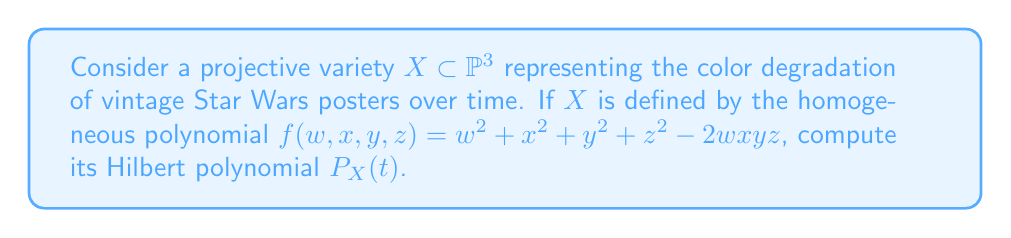Could you help me with this problem? To compute the Hilbert polynomial for this projective variety, we'll follow these steps:

1) First, we need to determine the degree of the variety. The polynomial $f$ has degree 2, so $X$ is a quadric surface in $\mathbb{P}^3$.

2) For a hypersurface of degree $d$ in $\mathbb{P}^n$, the Hilbert polynomial is given by:

   $$P_X(t) = \binom{n+t}{n} - \binom{n+t-d}{n}$$

3) In our case, $n=3$ and $d=2$. Let's substitute these values:

   $$P_X(t) = \binom{3+t}{3} - \binom{3+t-2}{3} = \binom{t+3}{3} - \binom{t+1}{3}$$

4) Expand the binomial coefficients:

   $$P_X(t) = \frac{(t+3)(t+2)(t+1)}{3!} - \frac{(t+1)t(t-1)}{3!}$$

5) Simplify:

   $$P_X(t) = \frac{(t+3)(t+2)(t+1) - (t+1)t(t-1)}{6}$$

6) Expand the numerator:

   $$P_X(t) = \frac{(t^3 + 6t^2 + 11t + 6) - (t^3 + t^2 - t)}{6}$$

7) Simplify:

   $$P_X(t) = \frac{5t^2 + 12t + 6}{6} = \frac{1}{6}(5t^2 + 12t + 6)$$

This is the Hilbert polynomial for the projective variety $X$.
Answer: $P_X(t) = \frac{1}{6}(5t^2 + 12t + 6)$ 